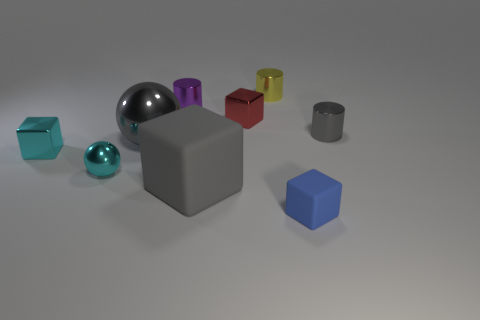Subtract 1 blocks. How many blocks are left? 3 Add 1 tiny matte cylinders. How many objects exist? 10 Subtract all cylinders. How many objects are left? 6 Subtract all small metal cubes. Subtract all gray cylinders. How many objects are left? 6 Add 6 big gray metallic objects. How many big gray metallic objects are left? 7 Add 8 blue matte cubes. How many blue matte cubes exist? 9 Subtract 0 green cylinders. How many objects are left? 9 